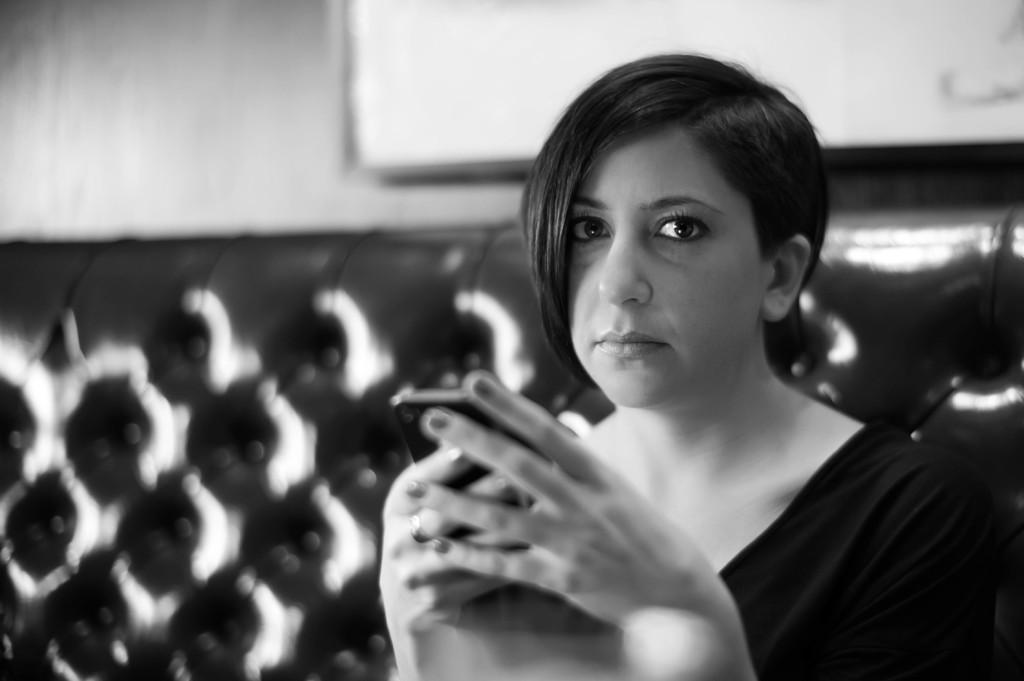What is the color scheme of the image? The image is black and white. Who is present in the image? There is a woman in the image. What is the woman holding in the image? The woman is holding a cellphone. Where is the woman sitting in the image? The woman is sitting on a sofa. What can be seen in the background of the image? There is a wall in the background of the image. What type of clover is growing on the wall in the image? There is no clover present in the image; the background features a wall without any plants. What is the title of the image? The image does not have a title, as it is a photograph and not a piece of artwork with a title. 